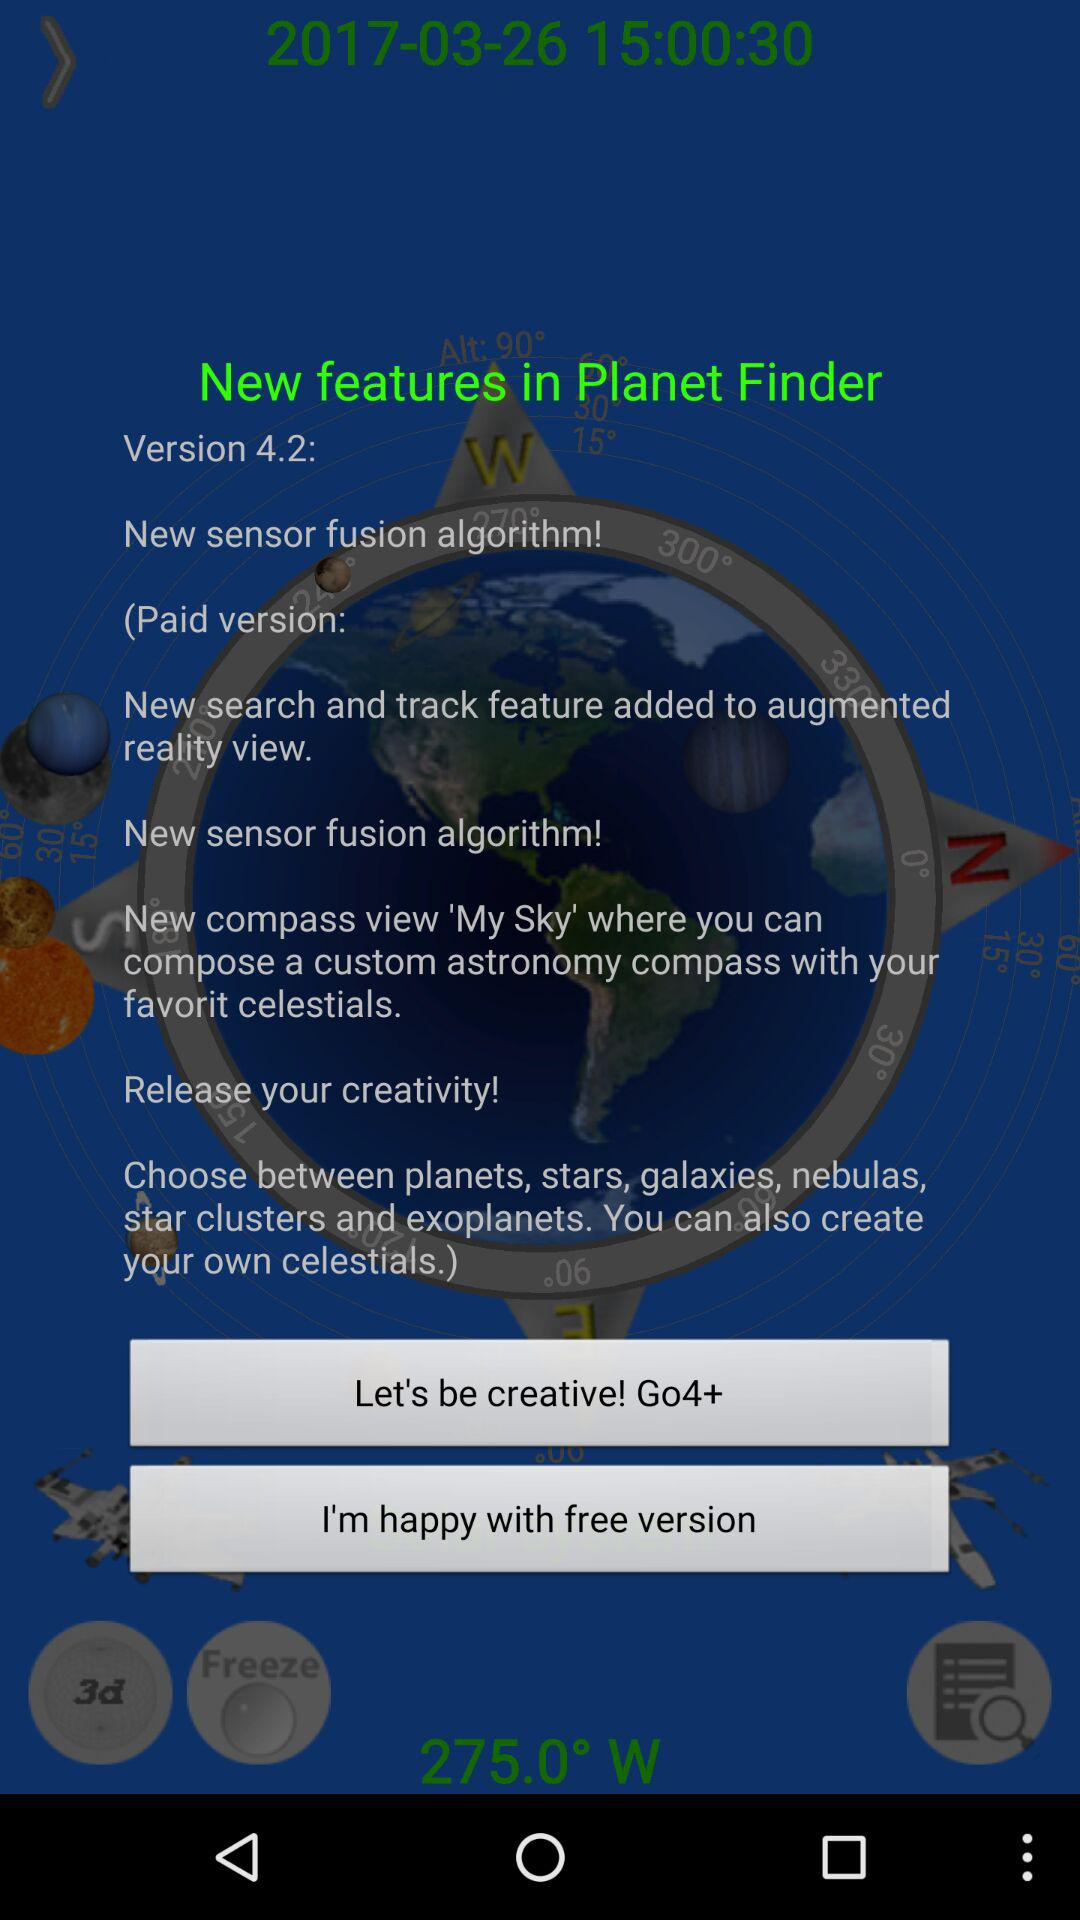Which version is used? The used version is 4.2. 